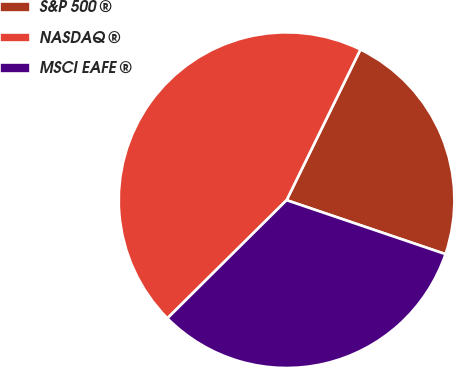<chart> <loc_0><loc_0><loc_500><loc_500><pie_chart><fcel>S&P 500 ®<fcel>NASDAQ ®<fcel>MSCI EAFE ®<nl><fcel>22.96%<fcel>44.68%<fcel>32.36%<nl></chart> 